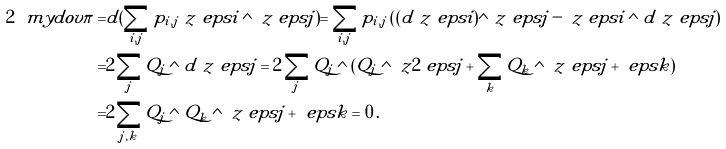Convert formula to latex. <formula><loc_0><loc_0><loc_500><loc_500>2 \ m y d o v \pi = & d ( \sum _ { i , j } p _ { i , j } \ z { \ e p s { i } } \wedge \ z { \ e p s { j } } ) = \sum _ { i , j } p _ { i , j } \left ( ( d \ z { \ e p s { i } } ) \wedge \ z { \ e p s { j } } - \ z { \ e p s { i } } \wedge d \ z { \ e p s { j } } \right ) \\ = & 2 \sum _ { j } Q _ { j } \wedge d \ z { \ e p s { j } } = 2 \sum _ { j } Q _ { j } \wedge ( Q _ { j } \wedge \ z { 2 \ e p s { j } } + \sum _ { k } Q _ { k } \wedge \ z { \ e p s { j } + \ e p s { k } } ) \\ = & 2 \sum _ { j , k } Q _ { j } \wedge Q _ { k } \wedge \ z { \ e p s { j } + \ e p s { k } } = 0 \, .</formula> 